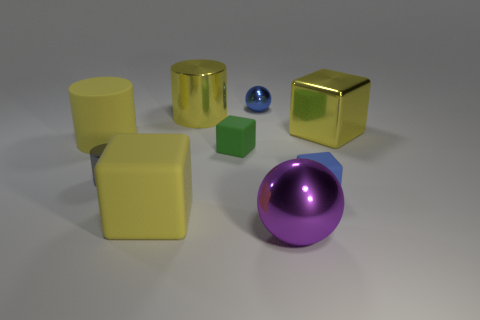Do the large metallic cube and the large metallic cylinder have the same color?
Offer a very short reply. Yes. What number of other objects are there of the same shape as the small blue metal thing?
Ensure brevity in your answer.  1. Are there more small rubber cubes that are on the left side of the yellow matte cylinder than objects that are to the right of the big purple metallic ball?
Give a very brief answer. No. There is a yellow metal thing to the right of the purple metallic object; does it have the same size as the blue object that is in front of the tiny sphere?
Your answer should be very brief. No. The large purple object is what shape?
Provide a succinct answer. Sphere. There is another cube that is the same color as the large metallic cube; what size is it?
Your response must be concise. Large. There is another large block that is the same material as the blue cube; what color is it?
Your response must be concise. Yellow. Is the tiny blue block made of the same material as the small block on the left side of the small blue metal sphere?
Offer a very short reply. Yes. What color is the small ball?
Give a very brief answer. Blue. What size is the yellow cylinder that is made of the same material as the blue sphere?
Offer a terse response. Large. 